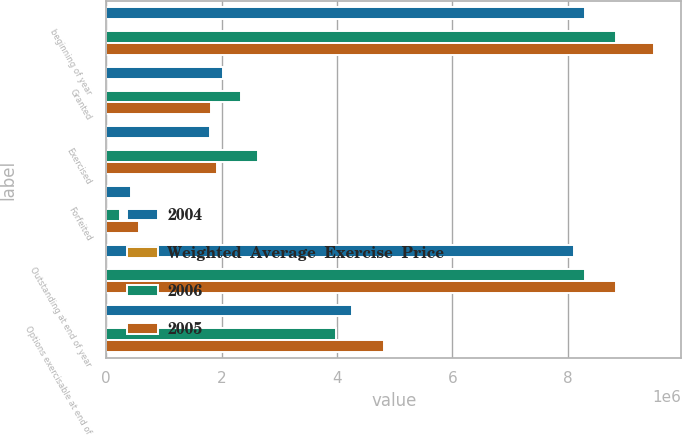<chart> <loc_0><loc_0><loc_500><loc_500><stacked_bar_chart><ecel><fcel>beginning of year<fcel>Granted<fcel>Exercised<fcel>Forfeited<fcel>Outstanding at end of year<fcel>Options exercisable at end of<nl><fcel>2004<fcel>8.30141e+06<fcel>2.0307e+06<fcel>1.80565e+06<fcel>423568<fcel>8.10289e+06<fcel>4.26274e+06<nl><fcel>Weighted  Average  Exercise  Price<fcel>19.38<fcel>38.17<fcel>17.06<fcel>26.09<fcel>24.26<fcel>18.03<nl><fcel>2006<fcel>8.83271e+06<fcel>2.33665e+06<fcel>2.63325e+06<fcel>234708<fcel>8.30141e+06<fcel>3.98775e+06<nl><fcel>2005<fcel>9.49036e+06<fcel>1.82047e+06<fcel>1.91678e+06<fcel>561336<fcel>8.83271e+06<fcel>4.81316e+06<nl></chart> 